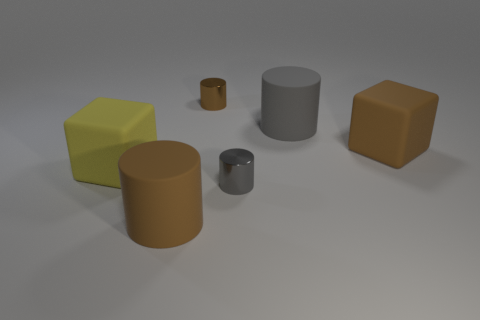Subtract all cyan blocks. How many gray cylinders are left? 2 Subtract all large brown rubber cylinders. How many cylinders are left? 3 Add 4 tiny gray shiny cylinders. How many objects exist? 10 Subtract all blue cylinders. Subtract all yellow cubes. How many cylinders are left? 4 Subtract all cubes. How many objects are left? 4 Subtract all large cubes. Subtract all large brown cubes. How many objects are left? 3 Add 4 matte cylinders. How many matte cylinders are left? 6 Add 4 yellow blocks. How many yellow blocks exist? 5 Subtract 0 cyan cylinders. How many objects are left? 6 